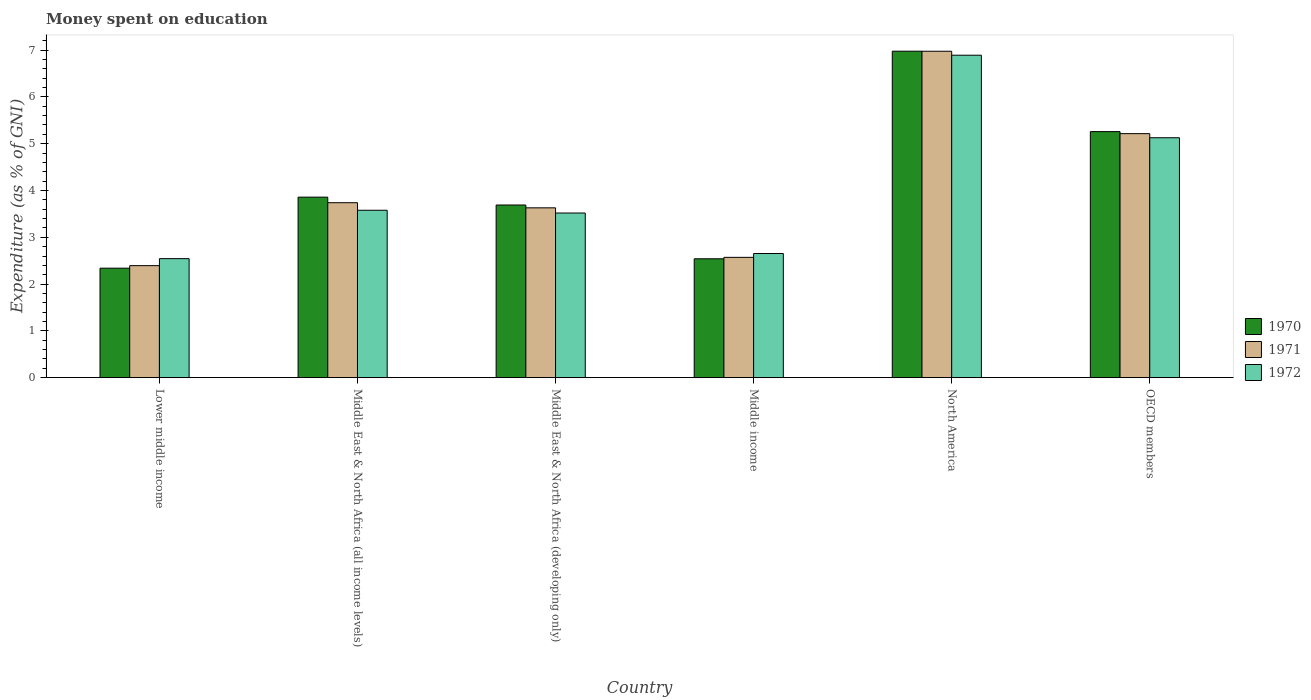Are the number of bars on each tick of the X-axis equal?
Give a very brief answer. Yes. How many bars are there on the 3rd tick from the left?
Offer a terse response. 3. In how many cases, is the number of bars for a given country not equal to the number of legend labels?
Provide a short and direct response. 0. What is the amount of money spent on education in 1972 in Lower middle income?
Your response must be concise. 2.54. Across all countries, what is the maximum amount of money spent on education in 1972?
Keep it short and to the point. 6.89. Across all countries, what is the minimum amount of money spent on education in 1971?
Provide a short and direct response. 2.39. In which country was the amount of money spent on education in 1971 minimum?
Provide a short and direct response. Lower middle income. What is the total amount of money spent on education in 1972 in the graph?
Ensure brevity in your answer.  24.31. What is the difference between the amount of money spent on education in 1972 in Middle East & North Africa (all income levels) and that in Middle East & North Africa (developing only)?
Offer a very short reply. 0.06. What is the difference between the amount of money spent on education in 1970 in Lower middle income and the amount of money spent on education in 1971 in OECD members?
Provide a short and direct response. -2.87. What is the average amount of money spent on education in 1972 per country?
Provide a short and direct response. 4.05. What is the difference between the amount of money spent on education of/in 1972 and amount of money spent on education of/in 1971 in OECD members?
Offer a terse response. -0.09. What is the ratio of the amount of money spent on education in 1971 in North America to that in OECD members?
Make the answer very short. 1.34. What is the difference between the highest and the second highest amount of money spent on education in 1971?
Your answer should be compact. -1.48. What is the difference between the highest and the lowest amount of money spent on education in 1972?
Offer a very short reply. 4.35. In how many countries, is the amount of money spent on education in 1970 greater than the average amount of money spent on education in 1970 taken over all countries?
Provide a short and direct response. 2. Is it the case that in every country, the sum of the amount of money spent on education in 1971 and amount of money spent on education in 1972 is greater than the amount of money spent on education in 1970?
Offer a very short reply. Yes. Are all the bars in the graph horizontal?
Ensure brevity in your answer.  No. What is the difference between two consecutive major ticks on the Y-axis?
Give a very brief answer. 1. Are the values on the major ticks of Y-axis written in scientific E-notation?
Keep it short and to the point. No. Does the graph contain grids?
Give a very brief answer. No. Where does the legend appear in the graph?
Your response must be concise. Center right. How many legend labels are there?
Make the answer very short. 3. How are the legend labels stacked?
Provide a succinct answer. Vertical. What is the title of the graph?
Offer a very short reply. Money spent on education. Does "2011" appear as one of the legend labels in the graph?
Give a very brief answer. No. What is the label or title of the X-axis?
Make the answer very short. Country. What is the label or title of the Y-axis?
Offer a terse response. Expenditure (as % of GNI). What is the Expenditure (as % of GNI) in 1970 in Lower middle income?
Make the answer very short. 2.34. What is the Expenditure (as % of GNI) in 1971 in Lower middle income?
Your answer should be very brief. 2.39. What is the Expenditure (as % of GNI) of 1972 in Lower middle income?
Make the answer very short. 2.54. What is the Expenditure (as % of GNI) in 1970 in Middle East & North Africa (all income levels)?
Your answer should be compact. 3.86. What is the Expenditure (as % of GNI) of 1971 in Middle East & North Africa (all income levels)?
Your response must be concise. 3.74. What is the Expenditure (as % of GNI) in 1972 in Middle East & North Africa (all income levels)?
Give a very brief answer. 3.58. What is the Expenditure (as % of GNI) of 1970 in Middle East & North Africa (developing only)?
Give a very brief answer. 3.69. What is the Expenditure (as % of GNI) of 1971 in Middle East & North Africa (developing only)?
Keep it short and to the point. 3.63. What is the Expenditure (as % of GNI) of 1972 in Middle East & North Africa (developing only)?
Your answer should be very brief. 3.52. What is the Expenditure (as % of GNI) in 1970 in Middle income?
Ensure brevity in your answer.  2.54. What is the Expenditure (as % of GNI) of 1971 in Middle income?
Make the answer very short. 2.57. What is the Expenditure (as % of GNI) in 1972 in Middle income?
Make the answer very short. 2.65. What is the Expenditure (as % of GNI) in 1970 in North America?
Provide a short and direct response. 6.98. What is the Expenditure (as % of GNI) of 1971 in North America?
Make the answer very short. 6.98. What is the Expenditure (as % of GNI) of 1972 in North America?
Keep it short and to the point. 6.89. What is the Expenditure (as % of GNI) of 1970 in OECD members?
Keep it short and to the point. 5.26. What is the Expenditure (as % of GNI) of 1971 in OECD members?
Provide a short and direct response. 5.21. What is the Expenditure (as % of GNI) of 1972 in OECD members?
Give a very brief answer. 5.13. Across all countries, what is the maximum Expenditure (as % of GNI) in 1970?
Provide a short and direct response. 6.98. Across all countries, what is the maximum Expenditure (as % of GNI) in 1971?
Ensure brevity in your answer.  6.98. Across all countries, what is the maximum Expenditure (as % of GNI) of 1972?
Give a very brief answer. 6.89. Across all countries, what is the minimum Expenditure (as % of GNI) in 1970?
Your response must be concise. 2.34. Across all countries, what is the minimum Expenditure (as % of GNI) in 1971?
Your answer should be compact. 2.39. Across all countries, what is the minimum Expenditure (as % of GNI) of 1972?
Ensure brevity in your answer.  2.54. What is the total Expenditure (as % of GNI) of 1970 in the graph?
Ensure brevity in your answer.  24.66. What is the total Expenditure (as % of GNI) in 1971 in the graph?
Your response must be concise. 24.52. What is the total Expenditure (as % of GNI) of 1972 in the graph?
Ensure brevity in your answer.  24.31. What is the difference between the Expenditure (as % of GNI) of 1970 in Lower middle income and that in Middle East & North Africa (all income levels)?
Provide a short and direct response. -1.52. What is the difference between the Expenditure (as % of GNI) in 1971 in Lower middle income and that in Middle East & North Africa (all income levels)?
Your answer should be very brief. -1.35. What is the difference between the Expenditure (as % of GNI) of 1972 in Lower middle income and that in Middle East & North Africa (all income levels)?
Provide a succinct answer. -1.03. What is the difference between the Expenditure (as % of GNI) of 1970 in Lower middle income and that in Middle East & North Africa (developing only)?
Ensure brevity in your answer.  -1.35. What is the difference between the Expenditure (as % of GNI) of 1971 in Lower middle income and that in Middle East & North Africa (developing only)?
Offer a very short reply. -1.24. What is the difference between the Expenditure (as % of GNI) of 1972 in Lower middle income and that in Middle East & North Africa (developing only)?
Make the answer very short. -0.97. What is the difference between the Expenditure (as % of GNI) of 1970 in Lower middle income and that in Middle income?
Give a very brief answer. -0.2. What is the difference between the Expenditure (as % of GNI) in 1971 in Lower middle income and that in Middle income?
Ensure brevity in your answer.  -0.18. What is the difference between the Expenditure (as % of GNI) in 1972 in Lower middle income and that in Middle income?
Keep it short and to the point. -0.11. What is the difference between the Expenditure (as % of GNI) in 1970 in Lower middle income and that in North America?
Your response must be concise. -4.64. What is the difference between the Expenditure (as % of GNI) in 1971 in Lower middle income and that in North America?
Give a very brief answer. -4.58. What is the difference between the Expenditure (as % of GNI) in 1972 in Lower middle income and that in North America?
Make the answer very short. -4.35. What is the difference between the Expenditure (as % of GNI) in 1970 in Lower middle income and that in OECD members?
Offer a very short reply. -2.92. What is the difference between the Expenditure (as % of GNI) in 1971 in Lower middle income and that in OECD members?
Offer a very short reply. -2.82. What is the difference between the Expenditure (as % of GNI) of 1972 in Lower middle income and that in OECD members?
Offer a very short reply. -2.58. What is the difference between the Expenditure (as % of GNI) in 1970 in Middle East & North Africa (all income levels) and that in Middle East & North Africa (developing only)?
Offer a very short reply. 0.17. What is the difference between the Expenditure (as % of GNI) of 1971 in Middle East & North Africa (all income levels) and that in Middle East & North Africa (developing only)?
Your answer should be compact. 0.11. What is the difference between the Expenditure (as % of GNI) of 1972 in Middle East & North Africa (all income levels) and that in Middle East & North Africa (developing only)?
Ensure brevity in your answer.  0.06. What is the difference between the Expenditure (as % of GNI) in 1970 in Middle East & North Africa (all income levels) and that in Middle income?
Your answer should be very brief. 1.32. What is the difference between the Expenditure (as % of GNI) in 1971 in Middle East & North Africa (all income levels) and that in Middle income?
Your response must be concise. 1.17. What is the difference between the Expenditure (as % of GNI) in 1972 in Middle East & North Africa (all income levels) and that in Middle income?
Your answer should be very brief. 0.92. What is the difference between the Expenditure (as % of GNI) of 1970 in Middle East & North Africa (all income levels) and that in North America?
Your answer should be compact. -3.12. What is the difference between the Expenditure (as % of GNI) in 1971 in Middle East & North Africa (all income levels) and that in North America?
Make the answer very short. -3.24. What is the difference between the Expenditure (as % of GNI) of 1972 in Middle East & North Africa (all income levels) and that in North America?
Offer a terse response. -3.31. What is the difference between the Expenditure (as % of GNI) of 1970 in Middle East & North Africa (all income levels) and that in OECD members?
Offer a terse response. -1.4. What is the difference between the Expenditure (as % of GNI) of 1971 in Middle East & North Africa (all income levels) and that in OECD members?
Give a very brief answer. -1.48. What is the difference between the Expenditure (as % of GNI) of 1972 in Middle East & North Africa (all income levels) and that in OECD members?
Ensure brevity in your answer.  -1.55. What is the difference between the Expenditure (as % of GNI) of 1970 in Middle East & North Africa (developing only) and that in Middle income?
Give a very brief answer. 1.15. What is the difference between the Expenditure (as % of GNI) in 1971 in Middle East & North Africa (developing only) and that in Middle income?
Make the answer very short. 1.06. What is the difference between the Expenditure (as % of GNI) of 1972 in Middle East & North Africa (developing only) and that in Middle income?
Offer a terse response. 0.86. What is the difference between the Expenditure (as % of GNI) in 1970 in Middle East & North Africa (developing only) and that in North America?
Offer a terse response. -3.29. What is the difference between the Expenditure (as % of GNI) in 1971 in Middle East & North Africa (developing only) and that in North America?
Provide a short and direct response. -3.35. What is the difference between the Expenditure (as % of GNI) in 1972 in Middle East & North Africa (developing only) and that in North America?
Your answer should be very brief. -3.37. What is the difference between the Expenditure (as % of GNI) of 1970 in Middle East & North Africa (developing only) and that in OECD members?
Offer a very short reply. -1.57. What is the difference between the Expenditure (as % of GNI) of 1971 in Middle East & North Africa (developing only) and that in OECD members?
Offer a very short reply. -1.59. What is the difference between the Expenditure (as % of GNI) in 1972 in Middle East & North Africa (developing only) and that in OECD members?
Your response must be concise. -1.61. What is the difference between the Expenditure (as % of GNI) in 1970 in Middle income and that in North America?
Give a very brief answer. -4.44. What is the difference between the Expenditure (as % of GNI) of 1971 in Middle income and that in North America?
Offer a very short reply. -4.41. What is the difference between the Expenditure (as % of GNI) of 1972 in Middle income and that in North America?
Ensure brevity in your answer.  -4.24. What is the difference between the Expenditure (as % of GNI) of 1970 in Middle income and that in OECD members?
Provide a short and direct response. -2.72. What is the difference between the Expenditure (as % of GNI) in 1971 in Middle income and that in OECD members?
Offer a very short reply. -2.64. What is the difference between the Expenditure (as % of GNI) of 1972 in Middle income and that in OECD members?
Offer a terse response. -2.47. What is the difference between the Expenditure (as % of GNI) in 1970 in North America and that in OECD members?
Your response must be concise. 1.72. What is the difference between the Expenditure (as % of GNI) of 1971 in North America and that in OECD members?
Make the answer very short. 1.76. What is the difference between the Expenditure (as % of GNI) in 1972 in North America and that in OECD members?
Keep it short and to the point. 1.76. What is the difference between the Expenditure (as % of GNI) of 1970 in Lower middle income and the Expenditure (as % of GNI) of 1971 in Middle East & North Africa (all income levels)?
Make the answer very short. -1.4. What is the difference between the Expenditure (as % of GNI) in 1970 in Lower middle income and the Expenditure (as % of GNI) in 1972 in Middle East & North Africa (all income levels)?
Make the answer very short. -1.24. What is the difference between the Expenditure (as % of GNI) in 1971 in Lower middle income and the Expenditure (as % of GNI) in 1972 in Middle East & North Africa (all income levels)?
Your answer should be compact. -1.18. What is the difference between the Expenditure (as % of GNI) in 1970 in Lower middle income and the Expenditure (as % of GNI) in 1971 in Middle East & North Africa (developing only)?
Keep it short and to the point. -1.29. What is the difference between the Expenditure (as % of GNI) of 1970 in Lower middle income and the Expenditure (as % of GNI) of 1972 in Middle East & North Africa (developing only)?
Your answer should be very brief. -1.18. What is the difference between the Expenditure (as % of GNI) of 1971 in Lower middle income and the Expenditure (as % of GNI) of 1972 in Middle East & North Africa (developing only)?
Provide a short and direct response. -1.12. What is the difference between the Expenditure (as % of GNI) of 1970 in Lower middle income and the Expenditure (as % of GNI) of 1971 in Middle income?
Provide a short and direct response. -0.23. What is the difference between the Expenditure (as % of GNI) in 1970 in Lower middle income and the Expenditure (as % of GNI) in 1972 in Middle income?
Ensure brevity in your answer.  -0.31. What is the difference between the Expenditure (as % of GNI) of 1971 in Lower middle income and the Expenditure (as % of GNI) of 1972 in Middle income?
Ensure brevity in your answer.  -0.26. What is the difference between the Expenditure (as % of GNI) of 1970 in Lower middle income and the Expenditure (as % of GNI) of 1971 in North America?
Make the answer very short. -4.64. What is the difference between the Expenditure (as % of GNI) of 1970 in Lower middle income and the Expenditure (as % of GNI) of 1972 in North America?
Offer a very short reply. -4.55. What is the difference between the Expenditure (as % of GNI) in 1971 in Lower middle income and the Expenditure (as % of GNI) in 1972 in North America?
Give a very brief answer. -4.5. What is the difference between the Expenditure (as % of GNI) in 1970 in Lower middle income and the Expenditure (as % of GNI) in 1971 in OECD members?
Give a very brief answer. -2.87. What is the difference between the Expenditure (as % of GNI) of 1970 in Lower middle income and the Expenditure (as % of GNI) of 1972 in OECD members?
Make the answer very short. -2.79. What is the difference between the Expenditure (as % of GNI) in 1971 in Lower middle income and the Expenditure (as % of GNI) in 1972 in OECD members?
Give a very brief answer. -2.73. What is the difference between the Expenditure (as % of GNI) of 1970 in Middle East & North Africa (all income levels) and the Expenditure (as % of GNI) of 1971 in Middle East & North Africa (developing only)?
Your answer should be compact. 0.23. What is the difference between the Expenditure (as % of GNI) of 1970 in Middle East & North Africa (all income levels) and the Expenditure (as % of GNI) of 1972 in Middle East & North Africa (developing only)?
Offer a terse response. 0.34. What is the difference between the Expenditure (as % of GNI) of 1971 in Middle East & North Africa (all income levels) and the Expenditure (as % of GNI) of 1972 in Middle East & North Africa (developing only)?
Offer a very short reply. 0.22. What is the difference between the Expenditure (as % of GNI) of 1970 in Middle East & North Africa (all income levels) and the Expenditure (as % of GNI) of 1971 in Middle income?
Your answer should be compact. 1.29. What is the difference between the Expenditure (as % of GNI) of 1970 in Middle East & North Africa (all income levels) and the Expenditure (as % of GNI) of 1972 in Middle income?
Make the answer very short. 1.2. What is the difference between the Expenditure (as % of GNI) in 1971 in Middle East & North Africa (all income levels) and the Expenditure (as % of GNI) in 1972 in Middle income?
Keep it short and to the point. 1.09. What is the difference between the Expenditure (as % of GNI) of 1970 in Middle East & North Africa (all income levels) and the Expenditure (as % of GNI) of 1971 in North America?
Offer a terse response. -3.12. What is the difference between the Expenditure (as % of GNI) of 1970 in Middle East & North Africa (all income levels) and the Expenditure (as % of GNI) of 1972 in North America?
Make the answer very short. -3.03. What is the difference between the Expenditure (as % of GNI) of 1971 in Middle East & North Africa (all income levels) and the Expenditure (as % of GNI) of 1972 in North America?
Offer a very short reply. -3.15. What is the difference between the Expenditure (as % of GNI) of 1970 in Middle East & North Africa (all income levels) and the Expenditure (as % of GNI) of 1971 in OECD members?
Make the answer very short. -1.36. What is the difference between the Expenditure (as % of GNI) of 1970 in Middle East & North Africa (all income levels) and the Expenditure (as % of GNI) of 1972 in OECD members?
Your answer should be very brief. -1.27. What is the difference between the Expenditure (as % of GNI) of 1971 in Middle East & North Africa (all income levels) and the Expenditure (as % of GNI) of 1972 in OECD members?
Provide a succinct answer. -1.39. What is the difference between the Expenditure (as % of GNI) of 1970 in Middle East & North Africa (developing only) and the Expenditure (as % of GNI) of 1971 in Middle income?
Your answer should be compact. 1.12. What is the difference between the Expenditure (as % of GNI) of 1970 in Middle East & North Africa (developing only) and the Expenditure (as % of GNI) of 1972 in Middle income?
Provide a short and direct response. 1.04. What is the difference between the Expenditure (as % of GNI) in 1971 in Middle East & North Africa (developing only) and the Expenditure (as % of GNI) in 1972 in Middle income?
Provide a succinct answer. 0.98. What is the difference between the Expenditure (as % of GNI) in 1970 in Middle East & North Africa (developing only) and the Expenditure (as % of GNI) in 1971 in North America?
Make the answer very short. -3.29. What is the difference between the Expenditure (as % of GNI) in 1970 in Middle East & North Africa (developing only) and the Expenditure (as % of GNI) in 1972 in North America?
Offer a very short reply. -3.2. What is the difference between the Expenditure (as % of GNI) of 1971 in Middle East & North Africa (developing only) and the Expenditure (as % of GNI) of 1972 in North America?
Provide a succinct answer. -3.26. What is the difference between the Expenditure (as % of GNI) of 1970 in Middle East & North Africa (developing only) and the Expenditure (as % of GNI) of 1971 in OECD members?
Your answer should be very brief. -1.52. What is the difference between the Expenditure (as % of GNI) of 1970 in Middle East & North Africa (developing only) and the Expenditure (as % of GNI) of 1972 in OECD members?
Provide a short and direct response. -1.44. What is the difference between the Expenditure (as % of GNI) of 1971 in Middle East & North Africa (developing only) and the Expenditure (as % of GNI) of 1972 in OECD members?
Offer a terse response. -1.5. What is the difference between the Expenditure (as % of GNI) in 1970 in Middle income and the Expenditure (as % of GNI) in 1971 in North America?
Provide a short and direct response. -4.44. What is the difference between the Expenditure (as % of GNI) of 1970 in Middle income and the Expenditure (as % of GNI) of 1972 in North America?
Make the answer very short. -4.35. What is the difference between the Expenditure (as % of GNI) of 1971 in Middle income and the Expenditure (as % of GNI) of 1972 in North America?
Offer a very short reply. -4.32. What is the difference between the Expenditure (as % of GNI) of 1970 in Middle income and the Expenditure (as % of GNI) of 1971 in OECD members?
Your answer should be compact. -2.67. What is the difference between the Expenditure (as % of GNI) of 1970 in Middle income and the Expenditure (as % of GNI) of 1972 in OECD members?
Provide a succinct answer. -2.59. What is the difference between the Expenditure (as % of GNI) in 1971 in Middle income and the Expenditure (as % of GNI) in 1972 in OECD members?
Your answer should be very brief. -2.56. What is the difference between the Expenditure (as % of GNI) in 1970 in North America and the Expenditure (as % of GNI) in 1971 in OECD members?
Offer a very short reply. 1.76. What is the difference between the Expenditure (as % of GNI) of 1970 in North America and the Expenditure (as % of GNI) of 1972 in OECD members?
Ensure brevity in your answer.  1.85. What is the difference between the Expenditure (as % of GNI) in 1971 in North America and the Expenditure (as % of GNI) in 1972 in OECD members?
Provide a succinct answer. 1.85. What is the average Expenditure (as % of GNI) of 1970 per country?
Offer a very short reply. 4.11. What is the average Expenditure (as % of GNI) in 1971 per country?
Your response must be concise. 4.09. What is the average Expenditure (as % of GNI) in 1972 per country?
Offer a very short reply. 4.05. What is the difference between the Expenditure (as % of GNI) in 1970 and Expenditure (as % of GNI) in 1971 in Lower middle income?
Provide a short and direct response. -0.05. What is the difference between the Expenditure (as % of GNI) of 1970 and Expenditure (as % of GNI) of 1972 in Lower middle income?
Offer a very short reply. -0.2. What is the difference between the Expenditure (as % of GNI) in 1971 and Expenditure (as % of GNI) in 1972 in Lower middle income?
Provide a succinct answer. -0.15. What is the difference between the Expenditure (as % of GNI) of 1970 and Expenditure (as % of GNI) of 1971 in Middle East & North Africa (all income levels)?
Offer a very short reply. 0.12. What is the difference between the Expenditure (as % of GNI) in 1970 and Expenditure (as % of GNI) in 1972 in Middle East & North Africa (all income levels)?
Give a very brief answer. 0.28. What is the difference between the Expenditure (as % of GNI) in 1971 and Expenditure (as % of GNI) in 1972 in Middle East & North Africa (all income levels)?
Provide a short and direct response. 0.16. What is the difference between the Expenditure (as % of GNI) in 1970 and Expenditure (as % of GNI) in 1971 in Middle East & North Africa (developing only)?
Ensure brevity in your answer.  0.06. What is the difference between the Expenditure (as % of GNI) in 1970 and Expenditure (as % of GNI) in 1972 in Middle East & North Africa (developing only)?
Give a very brief answer. 0.17. What is the difference between the Expenditure (as % of GNI) of 1971 and Expenditure (as % of GNI) of 1972 in Middle East & North Africa (developing only)?
Your answer should be compact. 0.11. What is the difference between the Expenditure (as % of GNI) in 1970 and Expenditure (as % of GNI) in 1971 in Middle income?
Your answer should be compact. -0.03. What is the difference between the Expenditure (as % of GNI) in 1970 and Expenditure (as % of GNI) in 1972 in Middle income?
Provide a short and direct response. -0.11. What is the difference between the Expenditure (as % of GNI) in 1971 and Expenditure (as % of GNI) in 1972 in Middle income?
Make the answer very short. -0.08. What is the difference between the Expenditure (as % of GNI) in 1970 and Expenditure (as % of GNI) in 1971 in North America?
Offer a terse response. 0. What is the difference between the Expenditure (as % of GNI) of 1970 and Expenditure (as % of GNI) of 1972 in North America?
Ensure brevity in your answer.  0.09. What is the difference between the Expenditure (as % of GNI) in 1971 and Expenditure (as % of GNI) in 1972 in North America?
Give a very brief answer. 0.08. What is the difference between the Expenditure (as % of GNI) of 1970 and Expenditure (as % of GNI) of 1971 in OECD members?
Provide a short and direct response. 0.04. What is the difference between the Expenditure (as % of GNI) of 1970 and Expenditure (as % of GNI) of 1972 in OECD members?
Keep it short and to the point. 0.13. What is the difference between the Expenditure (as % of GNI) of 1971 and Expenditure (as % of GNI) of 1972 in OECD members?
Your response must be concise. 0.09. What is the ratio of the Expenditure (as % of GNI) of 1970 in Lower middle income to that in Middle East & North Africa (all income levels)?
Offer a terse response. 0.61. What is the ratio of the Expenditure (as % of GNI) in 1971 in Lower middle income to that in Middle East & North Africa (all income levels)?
Your response must be concise. 0.64. What is the ratio of the Expenditure (as % of GNI) of 1972 in Lower middle income to that in Middle East & North Africa (all income levels)?
Your answer should be compact. 0.71. What is the ratio of the Expenditure (as % of GNI) in 1970 in Lower middle income to that in Middle East & North Africa (developing only)?
Give a very brief answer. 0.63. What is the ratio of the Expenditure (as % of GNI) of 1971 in Lower middle income to that in Middle East & North Africa (developing only)?
Your answer should be compact. 0.66. What is the ratio of the Expenditure (as % of GNI) of 1972 in Lower middle income to that in Middle East & North Africa (developing only)?
Provide a succinct answer. 0.72. What is the ratio of the Expenditure (as % of GNI) of 1970 in Lower middle income to that in Middle income?
Make the answer very short. 0.92. What is the ratio of the Expenditure (as % of GNI) in 1971 in Lower middle income to that in Middle income?
Ensure brevity in your answer.  0.93. What is the ratio of the Expenditure (as % of GNI) in 1972 in Lower middle income to that in Middle income?
Keep it short and to the point. 0.96. What is the ratio of the Expenditure (as % of GNI) of 1970 in Lower middle income to that in North America?
Offer a terse response. 0.34. What is the ratio of the Expenditure (as % of GNI) in 1971 in Lower middle income to that in North America?
Keep it short and to the point. 0.34. What is the ratio of the Expenditure (as % of GNI) in 1972 in Lower middle income to that in North America?
Your response must be concise. 0.37. What is the ratio of the Expenditure (as % of GNI) of 1970 in Lower middle income to that in OECD members?
Ensure brevity in your answer.  0.45. What is the ratio of the Expenditure (as % of GNI) of 1971 in Lower middle income to that in OECD members?
Provide a short and direct response. 0.46. What is the ratio of the Expenditure (as % of GNI) in 1972 in Lower middle income to that in OECD members?
Offer a very short reply. 0.5. What is the ratio of the Expenditure (as % of GNI) in 1970 in Middle East & North Africa (all income levels) to that in Middle East & North Africa (developing only)?
Make the answer very short. 1.05. What is the ratio of the Expenditure (as % of GNI) in 1971 in Middle East & North Africa (all income levels) to that in Middle East & North Africa (developing only)?
Give a very brief answer. 1.03. What is the ratio of the Expenditure (as % of GNI) of 1972 in Middle East & North Africa (all income levels) to that in Middle East & North Africa (developing only)?
Offer a terse response. 1.02. What is the ratio of the Expenditure (as % of GNI) in 1970 in Middle East & North Africa (all income levels) to that in Middle income?
Give a very brief answer. 1.52. What is the ratio of the Expenditure (as % of GNI) in 1971 in Middle East & North Africa (all income levels) to that in Middle income?
Keep it short and to the point. 1.45. What is the ratio of the Expenditure (as % of GNI) in 1972 in Middle East & North Africa (all income levels) to that in Middle income?
Offer a terse response. 1.35. What is the ratio of the Expenditure (as % of GNI) in 1970 in Middle East & North Africa (all income levels) to that in North America?
Offer a very short reply. 0.55. What is the ratio of the Expenditure (as % of GNI) in 1971 in Middle East & North Africa (all income levels) to that in North America?
Provide a succinct answer. 0.54. What is the ratio of the Expenditure (as % of GNI) of 1972 in Middle East & North Africa (all income levels) to that in North America?
Provide a succinct answer. 0.52. What is the ratio of the Expenditure (as % of GNI) of 1970 in Middle East & North Africa (all income levels) to that in OECD members?
Offer a very short reply. 0.73. What is the ratio of the Expenditure (as % of GNI) in 1971 in Middle East & North Africa (all income levels) to that in OECD members?
Your response must be concise. 0.72. What is the ratio of the Expenditure (as % of GNI) of 1972 in Middle East & North Africa (all income levels) to that in OECD members?
Your answer should be compact. 0.7. What is the ratio of the Expenditure (as % of GNI) in 1970 in Middle East & North Africa (developing only) to that in Middle income?
Offer a very short reply. 1.45. What is the ratio of the Expenditure (as % of GNI) of 1971 in Middle East & North Africa (developing only) to that in Middle income?
Give a very brief answer. 1.41. What is the ratio of the Expenditure (as % of GNI) in 1972 in Middle East & North Africa (developing only) to that in Middle income?
Ensure brevity in your answer.  1.33. What is the ratio of the Expenditure (as % of GNI) of 1970 in Middle East & North Africa (developing only) to that in North America?
Your answer should be compact. 0.53. What is the ratio of the Expenditure (as % of GNI) of 1971 in Middle East & North Africa (developing only) to that in North America?
Provide a short and direct response. 0.52. What is the ratio of the Expenditure (as % of GNI) in 1972 in Middle East & North Africa (developing only) to that in North America?
Your response must be concise. 0.51. What is the ratio of the Expenditure (as % of GNI) of 1970 in Middle East & North Africa (developing only) to that in OECD members?
Your response must be concise. 0.7. What is the ratio of the Expenditure (as % of GNI) in 1971 in Middle East & North Africa (developing only) to that in OECD members?
Make the answer very short. 0.7. What is the ratio of the Expenditure (as % of GNI) in 1972 in Middle East & North Africa (developing only) to that in OECD members?
Give a very brief answer. 0.69. What is the ratio of the Expenditure (as % of GNI) in 1970 in Middle income to that in North America?
Provide a succinct answer. 0.36. What is the ratio of the Expenditure (as % of GNI) in 1971 in Middle income to that in North America?
Your answer should be very brief. 0.37. What is the ratio of the Expenditure (as % of GNI) in 1972 in Middle income to that in North America?
Your answer should be compact. 0.39. What is the ratio of the Expenditure (as % of GNI) of 1970 in Middle income to that in OECD members?
Offer a terse response. 0.48. What is the ratio of the Expenditure (as % of GNI) in 1971 in Middle income to that in OECD members?
Keep it short and to the point. 0.49. What is the ratio of the Expenditure (as % of GNI) of 1972 in Middle income to that in OECD members?
Keep it short and to the point. 0.52. What is the ratio of the Expenditure (as % of GNI) in 1970 in North America to that in OECD members?
Your answer should be very brief. 1.33. What is the ratio of the Expenditure (as % of GNI) of 1971 in North America to that in OECD members?
Offer a terse response. 1.34. What is the ratio of the Expenditure (as % of GNI) of 1972 in North America to that in OECD members?
Give a very brief answer. 1.34. What is the difference between the highest and the second highest Expenditure (as % of GNI) in 1970?
Your answer should be very brief. 1.72. What is the difference between the highest and the second highest Expenditure (as % of GNI) of 1971?
Provide a succinct answer. 1.76. What is the difference between the highest and the second highest Expenditure (as % of GNI) of 1972?
Make the answer very short. 1.76. What is the difference between the highest and the lowest Expenditure (as % of GNI) of 1970?
Your response must be concise. 4.64. What is the difference between the highest and the lowest Expenditure (as % of GNI) of 1971?
Offer a terse response. 4.58. What is the difference between the highest and the lowest Expenditure (as % of GNI) in 1972?
Give a very brief answer. 4.35. 